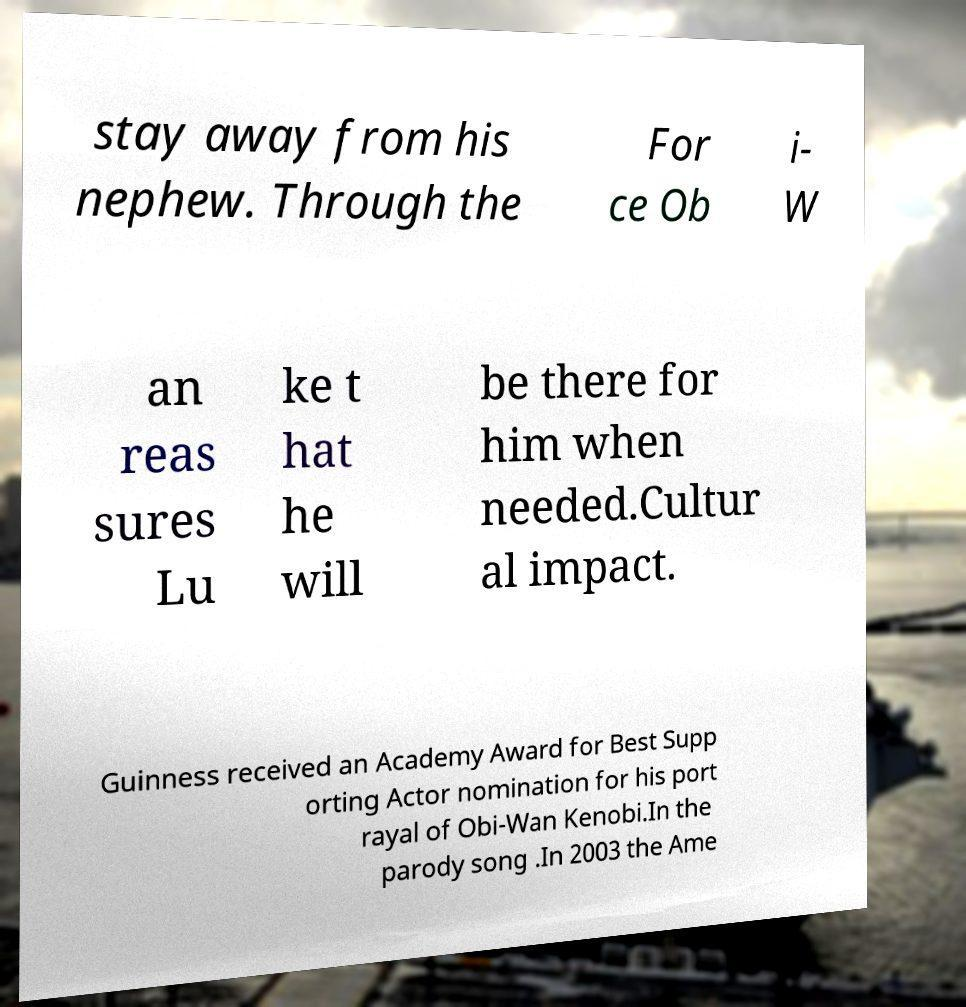For documentation purposes, I need the text within this image transcribed. Could you provide that? stay away from his nephew. Through the For ce Ob i- W an reas sures Lu ke t hat he will be there for him when needed.Cultur al impact. Guinness received an Academy Award for Best Supp orting Actor nomination for his port rayal of Obi-Wan Kenobi.In the parody song .In 2003 the Ame 